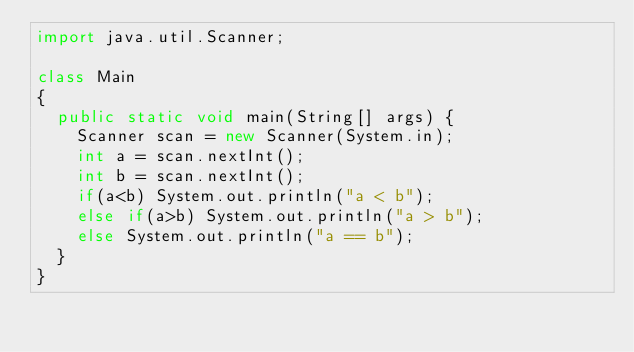<code> <loc_0><loc_0><loc_500><loc_500><_Java_>import java.util.Scanner;

class Main
{
  public static void main(String[] args) {
    Scanner scan = new Scanner(System.in);
    int a = scan.nextInt();
    int b = scan.nextInt();
    if(a<b) System.out.println("a < b");
    else if(a>b) System.out.println("a > b");
    else System.out.println("a == b");
  }
}</code> 